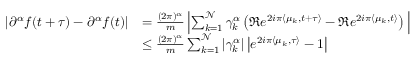<formula> <loc_0><loc_0><loc_500><loc_500>\begin{array} { r l } { | \partial ^ { \alpha } f ( t + \tau ) - \partial ^ { \alpha } f ( t ) | } & { = \frac { ( 2 \pi ) ^ { \alpha } } { m } \left | \sum _ { k = 1 } ^ { \mathcal { N } } \gamma _ { k } ^ { \alpha } \left ( \Re e ^ { 2 i \pi \langle \mu _ { k } , t + \tau \rangle } - \Re e ^ { 2 i \pi \langle \mu _ { k } , t \rangle } \right ) \, \right | } \\ & { \leq \frac { ( 2 \pi ) ^ { \alpha } } { m } \sum _ { k = 1 } ^ { \mathcal { N } } | \gamma _ { k } ^ { \alpha } | \left | e ^ { 2 i \pi \langle \mu _ { k } , \tau \rangle } - 1 \right | } \end{array}</formula> 